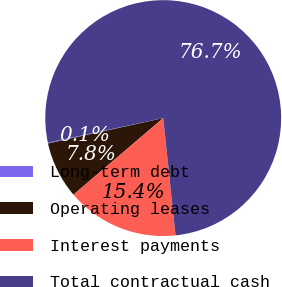<chart> <loc_0><loc_0><loc_500><loc_500><pie_chart><fcel>Long-term debt<fcel>Operating leases<fcel>Interest payments<fcel>Total contractual cash<nl><fcel>0.13%<fcel>7.78%<fcel>15.43%<fcel>76.66%<nl></chart> 